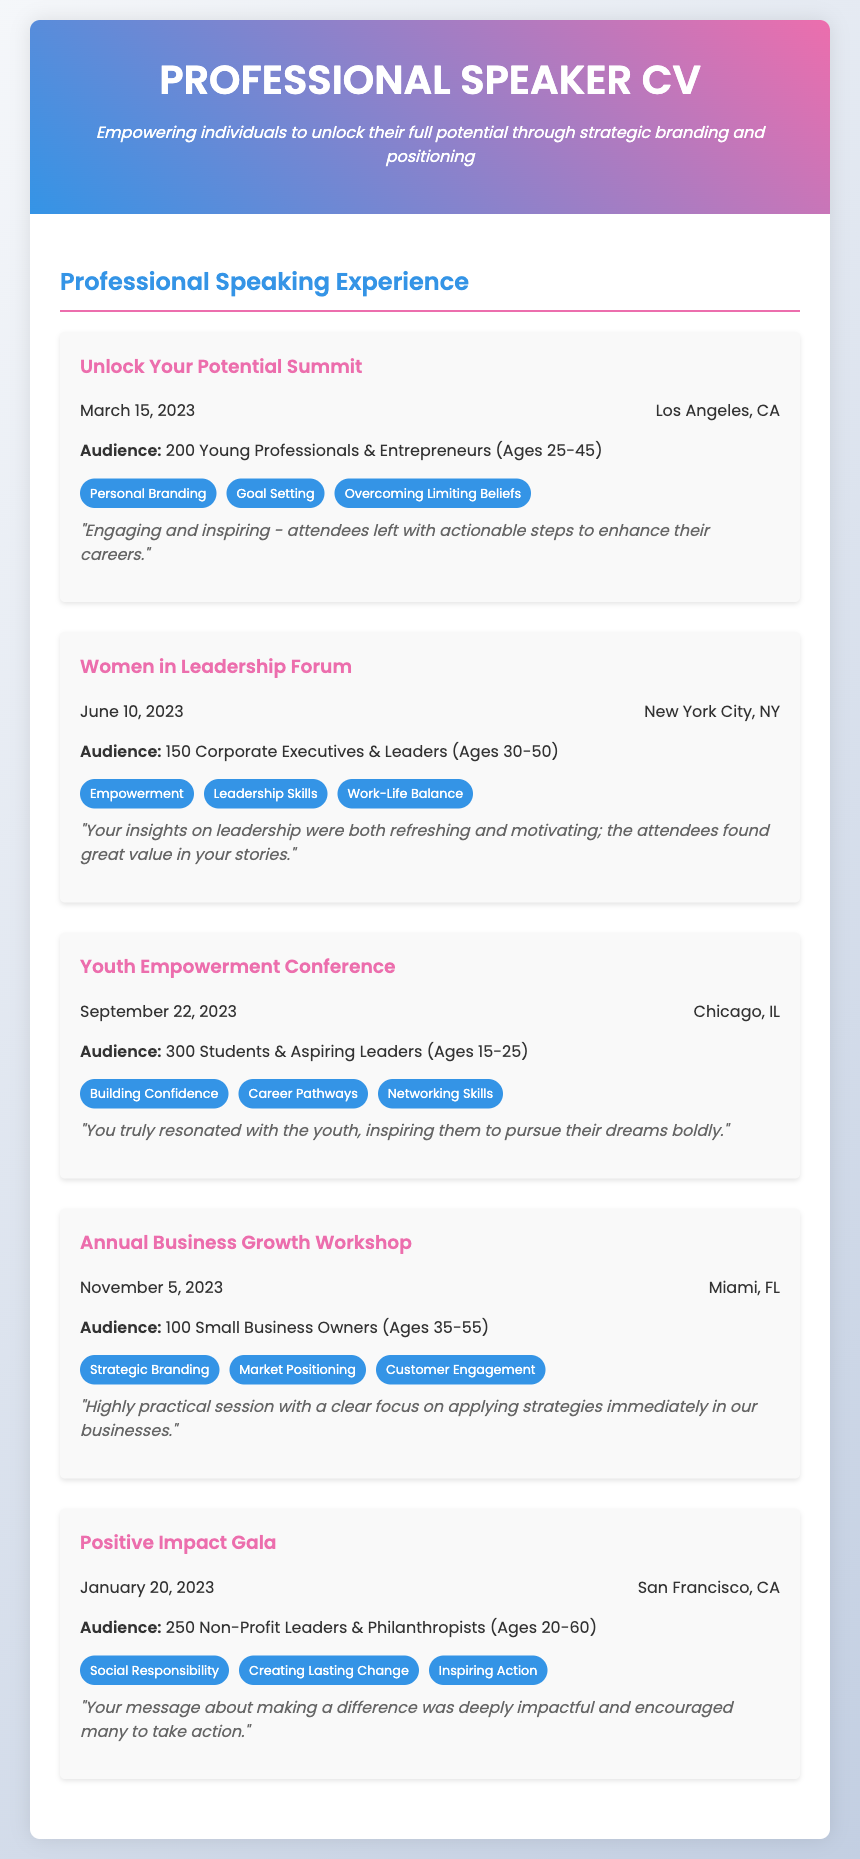What was the date of the Unlock Your Potential Summit? The document specifies that the Unlock Your Potential Summit took place on March 15, 2023.
Answer: March 15, 2023 How many attendees were present at the Youth Empowerment Conference? According to the document, 300 students and aspiring leaders attended the Youth Empowerment Conference.
Answer: 300 What key theme was addressed at the Women in Leadership Forum? The document lists Empowerment, Leadership Skills, and Work-Life Balance as the key themes discussed at the event.
Answer: Empowerment What type of audience attended the Annual Business Growth Workshop? The document states that the audience consisted of small business owners aged 35-55.
Answer: 100 Small Business Owners Which city hosted the Positive Impact Gala? The document mentions that the Positive Impact Gala was held in San Francisco, CA.
Answer: San Francisco, CA Which event took place in Chicago, IL? The document specifies the Youth Empowerment Conference as the event that took place in Chicago, IL.
Answer: Youth Empowerment Conference What feedback was received from the audience at the Annual Business Growth Workshop? The document records that the session was praised for its practical focus on applying strategies immediately in businesses.
Answer: Highly practical session What is the largest audience demographic mentioned in the document? The document shows that the Youth Empowerment Conference had the largest audience of 300 attendees.
Answer: 300 Students & Aspiring Leaders 